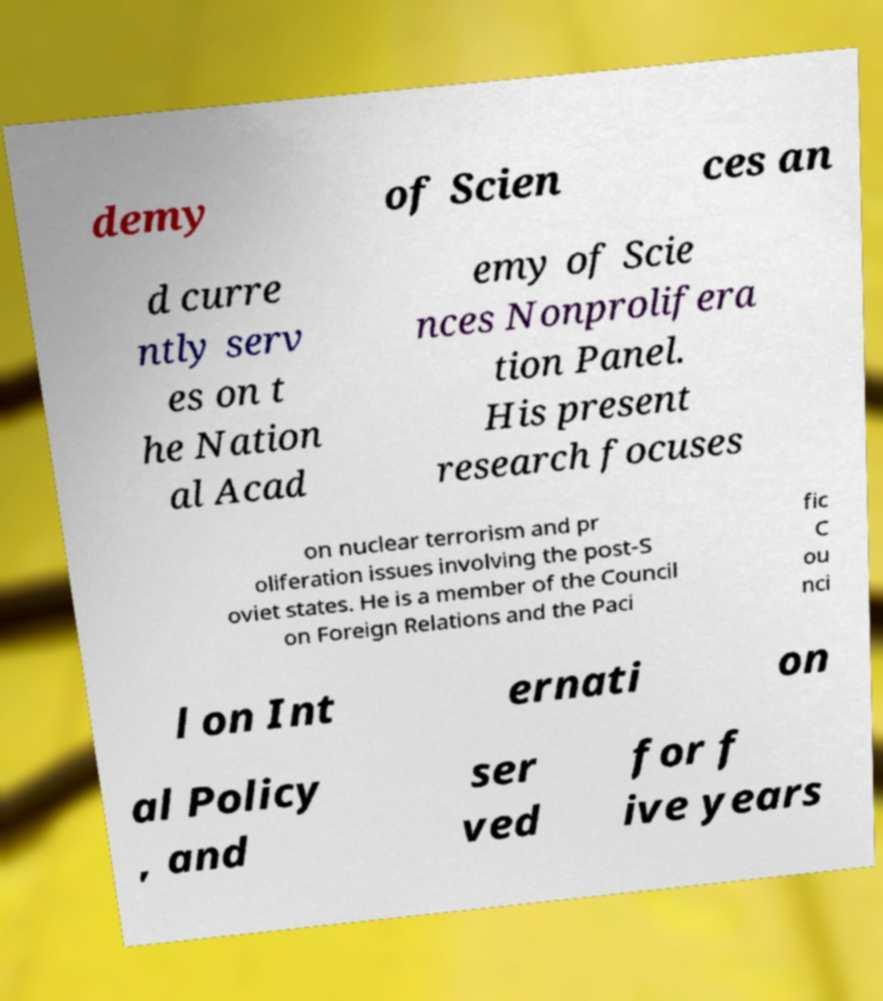Please identify and transcribe the text found in this image. demy of Scien ces an d curre ntly serv es on t he Nation al Acad emy of Scie nces Nonprolifera tion Panel. His present research focuses on nuclear terrorism and pr oliferation issues involving the post-S oviet states. He is a member of the Council on Foreign Relations and the Paci fic C ou nci l on Int ernati on al Policy , and ser ved for f ive years 